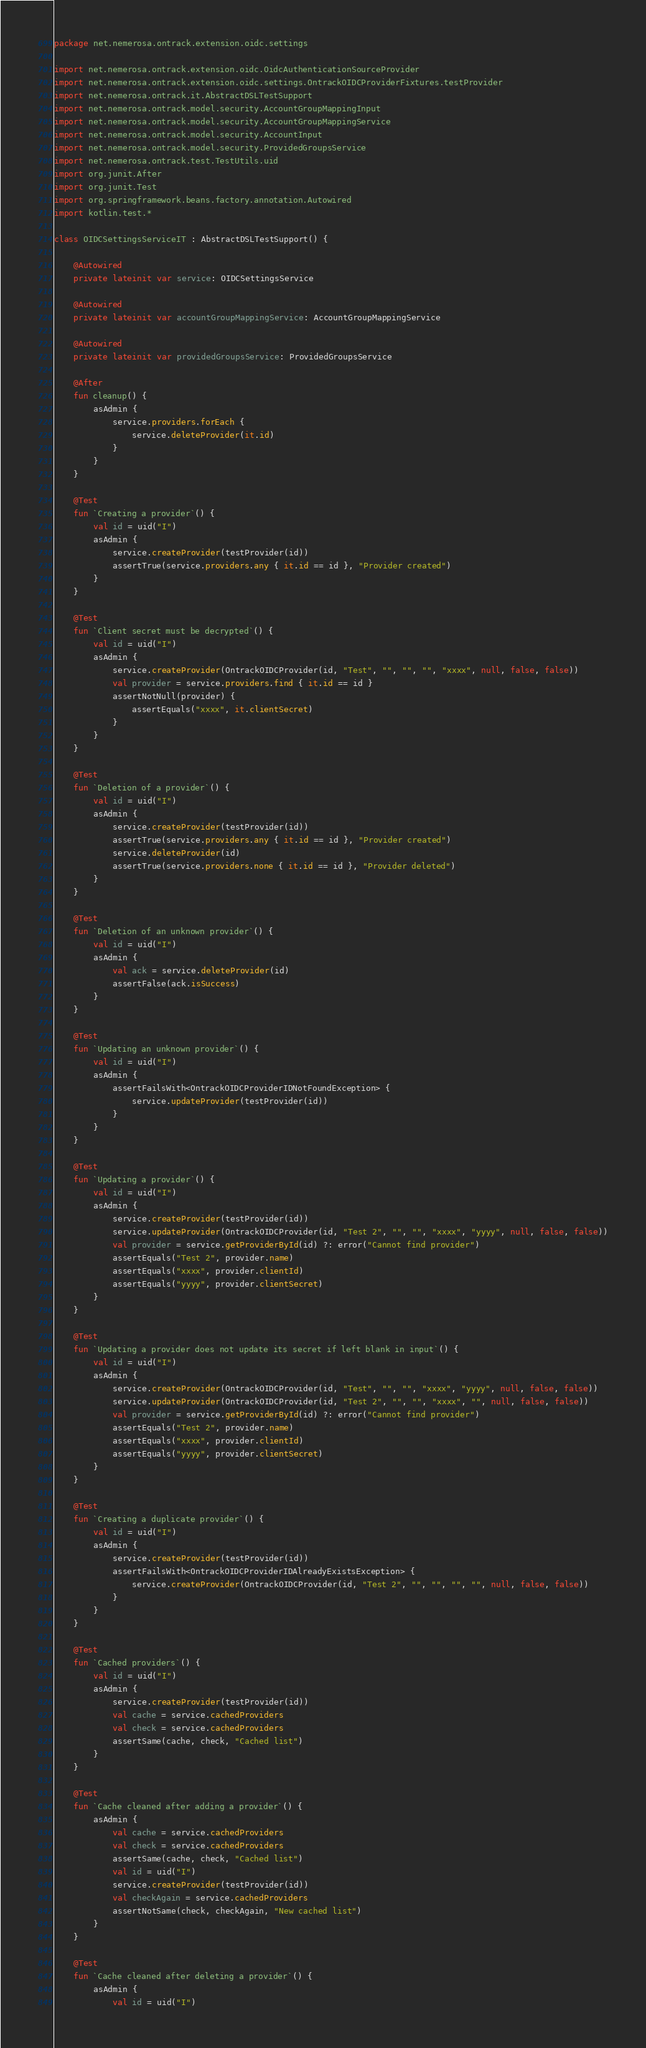Convert code to text. <code><loc_0><loc_0><loc_500><loc_500><_Kotlin_>package net.nemerosa.ontrack.extension.oidc.settings

import net.nemerosa.ontrack.extension.oidc.OidcAuthenticationSourceProvider
import net.nemerosa.ontrack.extension.oidc.settings.OntrackOIDCProviderFixtures.testProvider
import net.nemerosa.ontrack.it.AbstractDSLTestSupport
import net.nemerosa.ontrack.model.security.AccountGroupMappingInput
import net.nemerosa.ontrack.model.security.AccountGroupMappingService
import net.nemerosa.ontrack.model.security.AccountInput
import net.nemerosa.ontrack.model.security.ProvidedGroupsService
import net.nemerosa.ontrack.test.TestUtils.uid
import org.junit.After
import org.junit.Test
import org.springframework.beans.factory.annotation.Autowired
import kotlin.test.*

class OIDCSettingsServiceIT : AbstractDSLTestSupport() {

    @Autowired
    private lateinit var service: OIDCSettingsService

    @Autowired
    private lateinit var accountGroupMappingService: AccountGroupMappingService

    @Autowired
    private lateinit var providedGroupsService: ProvidedGroupsService

    @After
    fun cleanup() {
        asAdmin {
            service.providers.forEach {
                service.deleteProvider(it.id)
            }
        }
    }

    @Test
    fun `Creating a provider`() {
        val id = uid("I")
        asAdmin {
            service.createProvider(testProvider(id))
            assertTrue(service.providers.any { it.id == id }, "Provider created")
        }
    }

    @Test
    fun `Client secret must be decrypted`() {
        val id = uid("I")
        asAdmin {
            service.createProvider(OntrackOIDCProvider(id, "Test", "", "", "", "xxxx", null, false, false))
            val provider = service.providers.find { it.id == id }
            assertNotNull(provider) {
                assertEquals("xxxx", it.clientSecret)
            }
        }
    }

    @Test
    fun `Deletion of a provider`() {
        val id = uid("I")
        asAdmin {
            service.createProvider(testProvider(id))
            assertTrue(service.providers.any { it.id == id }, "Provider created")
            service.deleteProvider(id)
            assertTrue(service.providers.none { it.id == id }, "Provider deleted")
        }
    }

    @Test
    fun `Deletion of an unknown provider`() {
        val id = uid("I")
        asAdmin {
            val ack = service.deleteProvider(id)
            assertFalse(ack.isSuccess)
        }
    }

    @Test
    fun `Updating an unknown provider`() {
        val id = uid("I")
        asAdmin {
            assertFailsWith<OntrackOIDCProviderIDNotFoundException> {
                service.updateProvider(testProvider(id))
            }
        }
    }

    @Test
    fun `Updating a provider`() {
        val id = uid("I")
        asAdmin {
            service.createProvider(testProvider(id))
            service.updateProvider(OntrackOIDCProvider(id, "Test 2", "", "", "xxxx", "yyyy", null, false, false))
            val provider = service.getProviderById(id) ?: error("Cannot find provider")
            assertEquals("Test 2", provider.name)
            assertEquals("xxxx", provider.clientId)
            assertEquals("yyyy", provider.clientSecret)
        }
    }

    @Test
    fun `Updating a provider does not update its secret if left blank in input`() {
        val id = uid("I")
        asAdmin {
            service.createProvider(OntrackOIDCProvider(id, "Test", "", "", "xxxx", "yyyy", null, false, false))
            service.updateProvider(OntrackOIDCProvider(id, "Test 2", "", "", "xxxx", "", null, false, false))
            val provider = service.getProviderById(id) ?: error("Cannot find provider")
            assertEquals("Test 2", provider.name)
            assertEquals("xxxx", provider.clientId)
            assertEquals("yyyy", provider.clientSecret)
        }
    }

    @Test
    fun `Creating a duplicate provider`() {
        val id = uid("I")
        asAdmin {
            service.createProvider(testProvider(id))
            assertFailsWith<OntrackOIDCProviderIDAlreadyExistsException> {
                service.createProvider(OntrackOIDCProvider(id, "Test 2", "", "", "", "", null, false, false))
            }
        }
    }

    @Test
    fun `Cached providers`() {
        val id = uid("I")
        asAdmin {
            service.createProvider(testProvider(id))
            val cache = service.cachedProviders
            val check = service.cachedProviders
            assertSame(cache, check, "Cached list")
        }
    }

    @Test
    fun `Cache cleaned after adding a provider`() {
        asAdmin {
            val cache = service.cachedProviders
            val check = service.cachedProviders
            assertSame(cache, check, "Cached list")
            val id = uid("I")
            service.createProvider(testProvider(id))
            val checkAgain = service.cachedProviders
            assertNotSame(check, checkAgain, "New cached list")
        }
    }

    @Test
    fun `Cache cleaned after deleting a provider`() {
        asAdmin {
            val id = uid("I")</code> 